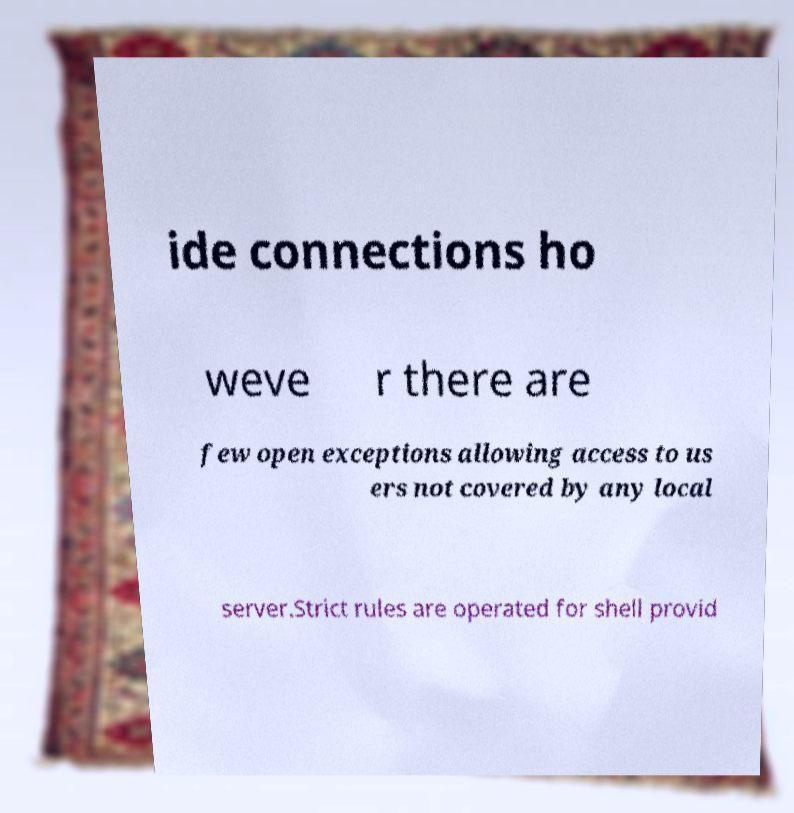I need the written content from this picture converted into text. Can you do that? ide connections ho weve r there are few open exceptions allowing access to us ers not covered by any local server.Strict rules are operated for shell provid 